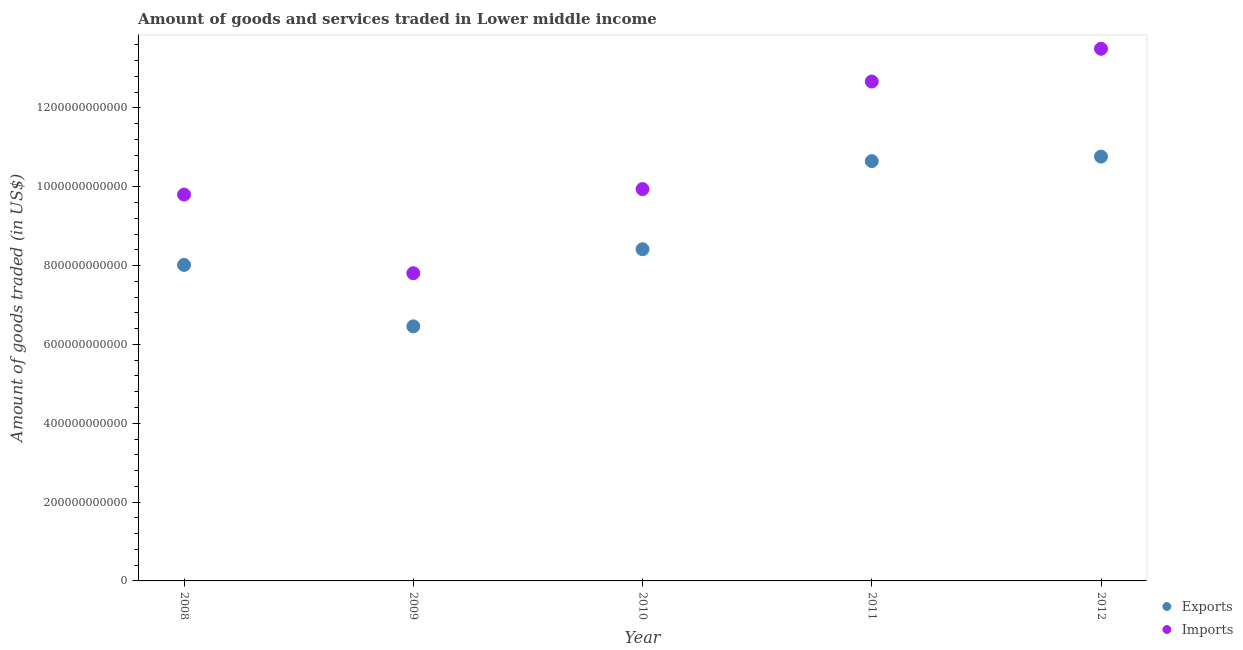Is the number of dotlines equal to the number of legend labels?
Ensure brevity in your answer.  Yes. What is the amount of goods exported in 2010?
Keep it short and to the point. 8.41e+11. Across all years, what is the maximum amount of goods exported?
Offer a terse response. 1.08e+12. Across all years, what is the minimum amount of goods imported?
Provide a short and direct response. 7.81e+11. What is the total amount of goods exported in the graph?
Keep it short and to the point. 4.43e+12. What is the difference between the amount of goods exported in 2011 and that in 2012?
Ensure brevity in your answer.  -1.15e+1. What is the difference between the amount of goods exported in 2012 and the amount of goods imported in 2008?
Provide a succinct answer. 9.63e+1. What is the average amount of goods exported per year?
Keep it short and to the point. 8.86e+11. In the year 2009, what is the difference between the amount of goods exported and amount of goods imported?
Offer a very short reply. -1.35e+11. What is the ratio of the amount of goods exported in 2011 to that in 2012?
Your response must be concise. 0.99. Is the difference between the amount of goods imported in 2010 and 2012 greater than the difference between the amount of goods exported in 2010 and 2012?
Your answer should be compact. No. What is the difference between the highest and the second highest amount of goods imported?
Offer a terse response. 8.32e+1. What is the difference between the highest and the lowest amount of goods exported?
Provide a short and direct response. 4.31e+11. Is the amount of goods imported strictly greater than the amount of goods exported over the years?
Make the answer very short. Yes. What is the difference between two consecutive major ticks on the Y-axis?
Provide a short and direct response. 2.00e+11. Are the values on the major ticks of Y-axis written in scientific E-notation?
Your answer should be very brief. No. Does the graph contain any zero values?
Ensure brevity in your answer.  No. Does the graph contain grids?
Your answer should be very brief. No. How many legend labels are there?
Offer a terse response. 2. What is the title of the graph?
Provide a succinct answer. Amount of goods and services traded in Lower middle income. Does "Electricity" appear as one of the legend labels in the graph?
Provide a short and direct response. No. What is the label or title of the Y-axis?
Offer a very short reply. Amount of goods traded (in US$). What is the Amount of goods traded (in US$) in Exports in 2008?
Your answer should be very brief. 8.02e+11. What is the Amount of goods traded (in US$) of Imports in 2008?
Offer a terse response. 9.80e+11. What is the Amount of goods traded (in US$) in Exports in 2009?
Keep it short and to the point. 6.46e+11. What is the Amount of goods traded (in US$) in Imports in 2009?
Offer a very short reply. 7.81e+11. What is the Amount of goods traded (in US$) in Exports in 2010?
Provide a succinct answer. 8.41e+11. What is the Amount of goods traded (in US$) in Imports in 2010?
Offer a terse response. 9.94e+11. What is the Amount of goods traded (in US$) in Exports in 2011?
Offer a terse response. 1.06e+12. What is the Amount of goods traded (in US$) of Imports in 2011?
Your answer should be very brief. 1.27e+12. What is the Amount of goods traded (in US$) in Exports in 2012?
Provide a succinct answer. 1.08e+12. What is the Amount of goods traded (in US$) in Imports in 2012?
Offer a very short reply. 1.35e+12. Across all years, what is the maximum Amount of goods traded (in US$) of Exports?
Your answer should be compact. 1.08e+12. Across all years, what is the maximum Amount of goods traded (in US$) in Imports?
Offer a very short reply. 1.35e+12. Across all years, what is the minimum Amount of goods traded (in US$) of Exports?
Offer a terse response. 6.46e+11. Across all years, what is the minimum Amount of goods traded (in US$) in Imports?
Keep it short and to the point. 7.81e+11. What is the total Amount of goods traded (in US$) of Exports in the graph?
Ensure brevity in your answer.  4.43e+12. What is the total Amount of goods traded (in US$) of Imports in the graph?
Your answer should be compact. 5.37e+12. What is the difference between the Amount of goods traded (in US$) in Exports in 2008 and that in 2009?
Your answer should be very brief. 1.56e+11. What is the difference between the Amount of goods traded (in US$) in Imports in 2008 and that in 2009?
Your answer should be compact. 1.99e+11. What is the difference between the Amount of goods traded (in US$) in Exports in 2008 and that in 2010?
Give a very brief answer. -3.98e+1. What is the difference between the Amount of goods traded (in US$) of Imports in 2008 and that in 2010?
Ensure brevity in your answer.  -1.39e+1. What is the difference between the Amount of goods traded (in US$) of Exports in 2008 and that in 2011?
Offer a terse response. -2.63e+11. What is the difference between the Amount of goods traded (in US$) in Imports in 2008 and that in 2011?
Provide a succinct answer. -2.87e+11. What is the difference between the Amount of goods traded (in US$) in Exports in 2008 and that in 2012?
Offer a very short reply. -2.75e+11. What is the difference between the Amount of goods traded (in US$) of Imports in 2008 and that in 2012?
Keep it short and to the point. -3.70e+11. What is the difference between the Amount of goods traded (in US$) of Exports in 2009 and that in 2010?
Give a very brief answer. -1.96e+11. What is the difference between the Amount of goods traded (in US$) of Imports in 2009 and that in 2010?
Ensure brevity in your answer.  -2.13e+11. What is the difference between the Amount of goods traded (in US$) in Exports in 2009 and that in 2011?
Provide a succinct answer. -4.19e+11. What is the difference between the Amount of goods traded (in US$) of Imports in 2009 and that in 2011?
Provide a short and direct response. -4.86e+11. What is the difference between the Amount of goods traded (in US$) of Exports in 2009 and that in 2012?
Provide a short and direct response. -4.31e+11. What is the difference between the Amount of goods traded (in US$) in Imports in 2009 and that in 2012?
Give a very brief answer. -5.69e+11. What is the difference between the Amount of goods traded (in US$) in Exports in 2010 and that in 2011?
Ensure brevity in your answer.  -2.23e+11. What is the difference between the Amount of goods traded (in US$) of Imports in 2010 and that in 2011?
Provide a succinct answer. -2.73e+11. What is the difference between the Amount of goods traded (in US$) of Exports in 2010 and that in 2012?
Keep it short and to the point. -2.35e+11. What is the difference between the Amount of goods traded (in US$) of Imports in 2010 and that in 2012?
Ensure brevity in your answer.  -3.56e+11. What is the difference between the Amount of goods traded (in US$) in Exports in 2011 and that in 2012?
Give a very brief answer. -1.15e+1. What is the difference between the Amount of goods traded (in US$) of Imports in 2011 and that in 2012?
Offer a very short reply. -8.32e+1. What is the difference between the Amount of goods traded (in US$) in Exports in 2008 and the Amount of goods traded (in US$) in Imports in 2009?
Keep it short and to the point. 2.10e+1. What is the difference between the Amount of goods traded (in US$) of Exports in 2008 and the Amount of goods traded (in US$) of Imports in 2010?
Keep it short and to the point. -1.92e+11. What is the difference between the Amount of goods traded (in US$) in Exports in 2008 and the Amount of goods traded (in US$) in Imports in 2011?
Your answer should be compact. -4.65e+11. What is the difference between the Amount of goods traded (in US$) of Exports in 2008 and the Amount of goods traded (in US$) of Imports in 2012?
Keep it short and to the point. -5.48e+11. What is the difference between the Amount of goods traded (in US$) in Exports in 2009 and the Amount of goods traded (in US$) in Imports in 2010?
Your answer should be compact. -3.48e+11. What is the difference between the Amount of goods traded (in US$) of Exports in 2009 and the Amount of goods traded (in US$) of Imports in 2011?
Keep it short and to the point. -6.21e+11. What is the difference between the Amount of goods traded (in US$) in Exports in 2009 and the Amount of goods traded (in US$) in Imports in 2012?
Offer a terse response. -7.04e+11. What is the difference between the Amount of goods traded (in US$) of Exports in 2010 and the Amount of goods traded (in US$) of Imports in 2011?
Give a very brief answer. -4.25e+11. What is the difference between the Amount of goods traded (in US$) of Exports in 2010 and the Amount of goods traded (in US$) of Imports in 2012?
Your answer should be very brief. -5.09e+11. What is the difference between the Amount of goods traded (in US$) of Exports in 2011 and the Amount of goods traded (in US$) of Imports in 2012?
Give a very brief answer. -2.85e+11. What is the average Amount of goods traded (in US$) of Exports per year?
Provide a short and direct response. 8.86e+11. What is the average Amount of goods traded (in US$) of Imports per year?
Keep it short and to the point. 1.07e+12. In the year 2008, what is the difference between the Amount of goods traded (in US$) in Exports and Amount of goods traded (in US$) in Imports?
Provide a succinct answer. -1.78e+11. In the year 2009, what is the difference between the Amount of goods traded (in US$) of Exports and Amount of goods traded (in US$) of Imports?
Keep it short and to the point. -1.35e+11. In the year 2010, what is the difference between the Amount of goods traded (in US$) of Exports and Amount of goods traded (in US$) of Imports?
Offer a terse response. -1.53e+11. In the year 2011, what is the difference between the Amount of goods traded (in US$) in Exports and Amount of goods traded (in US$) in Imports?
Keep it short and to the point. -2.02e+11. In the year 2012, what is the difference between the Amount of goods traded (in US$) of Exports and Amount of goods traded (in US$) of Imports?
Keep it short and to the point. -2.74e+11. What is the ratio of the Amount of goods traded (in US$) in Exports in 2008 to that in 2009?
Offer a terse response. 1.24. What is the ratio of the Amount of goods traded (in US$) of Imports in 2008 to that in 2009?
Offer a very short reply. 1.26. What is the ratio of the Amount of goods traded (in US$) of Exports in 2008 to that in 2010?
Your answer should be compact. 0.95. What is the ratio of the Amount of goods traded (in US$) in Imports in 2008 to that in 2010?
Give a very brief answer. 0.99. What is the ratio of the Amount of goods traded (in US$) in Exports in 2008 to that in 2011?
Provide a succinct answer. 0.75. What is the ratio of the Amount of goods traded (in US$) of Imports in 2008 to that in 2011?
Your response must be concise. 0.77. What is the ratio of the Amount of goods traded (in US$) in Exports in 2008 to that in 2012?
Provide a succinct answer. 0.74. What is the ratio of the Amount of goods traded (in US$) in Imports in 2008 to that in 2012?
Offer a very short reply. 0.73. What is the ratio of the Amount of goods traded (in US$) of Exports in 2009 to that in 2010?
Provide a short and direct response. 0.77. What is the ratio of the Amount of goods traded (in US$) in Imports in 2009 to that in 2010?
Give a very brief answer. 0.79. What is the ratio of the Amount of goods traded (in US$) in Exports in 2009 to that in 2011?
Your answer should be compact. 0.61. What is the ratio of the Amount of goods traded (in US$) in Imports in 2009 to that in 2011?
Give a very brief answer. 0.62. What is the ratio of the Amount of goods traded (in US$) of Exports in 2009 to that in 2012?
Your answer should be very brief. 0.6. What is the ratio of the Amount of goods traded (in US$) in Imports in 2009 to that in 2012?
Your answer should be very brief. 0.58. What is the ratio of the Amount of goods traded (in US$) of Exports in 2010 to that in 2011?
Offer a very short reply. 0.79. What is the ratio of the Amount of goods traded (in US$) of Imports in 2010 to that in 2011?
Provide a short and direct response. 0.78. What is the ratio of the Amount of goods traded (in US$) in Exports in 2010 to that in 2012?
Offer a terse response. 0.78. What is the ratio of the Amount of goods traded (in US$) in Imports in 2010 to that in 2012?
Make the answer very short. 0.74. What is the ratio of the Amount of goods traded (in US$) in Exports in 2011 to that in 2012?
Keep it short and to the point. 0.99. What is the ratio of the Amount of goods traded (in US$) of Imports in 2011 to that in 2012?
Keep it short and to the point. 0.94. What is the difference between the highest and the second highest Amount of goods traded (in US$) of Exports?
Ensure brevity in your answer.  1.15e+1. What is the difference between the highest and the second highest Amount of goods traded (in US$) in Imports?
Offer a terse response. 8.32e+1. What is the difference between the highest and the lowest Amount of goods traded (in US$) of Exports?
Your answer should be compact. 4.31e+11. What is the difference between the highest and the lowest Amount of goods traded (in US$) in Imports?
Provide a succinct answer. 5.69e+11. 